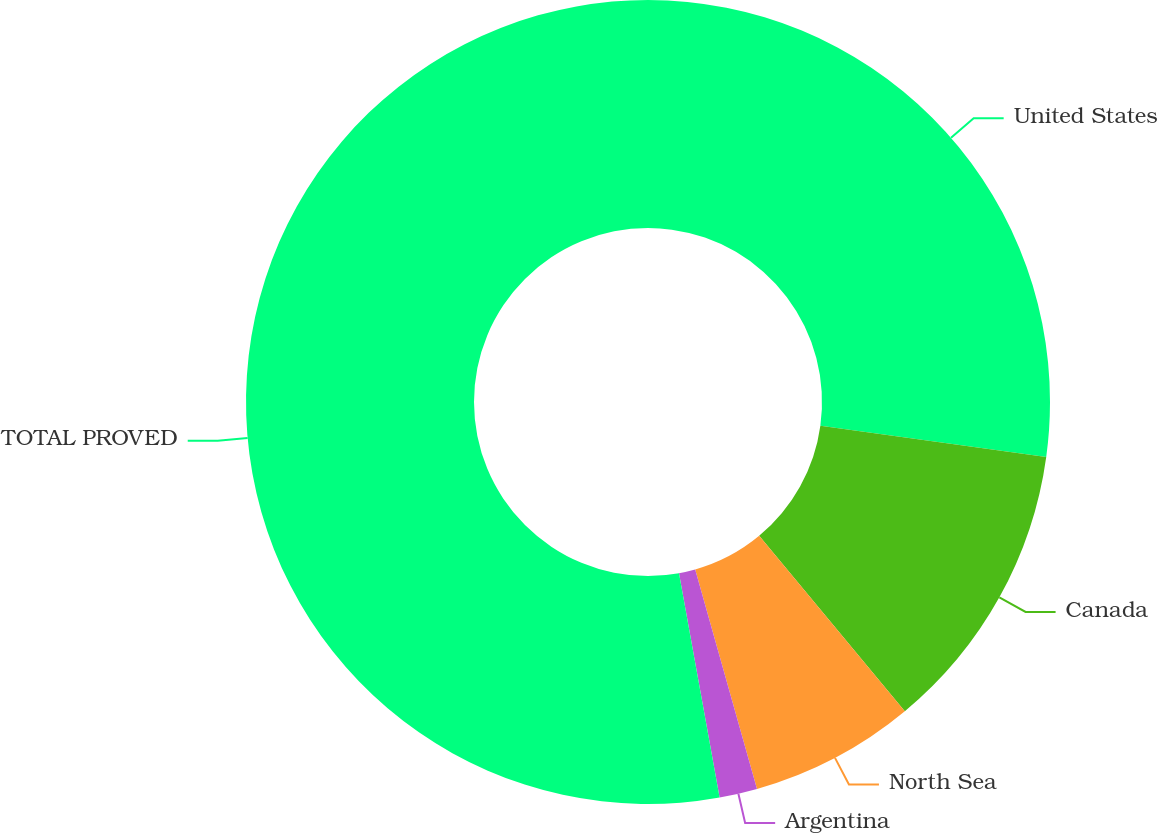Convert chart. <chart><loc_0><loc_0><loc_500><loc_500><pie_chart><fcel>United States<fcel>Canada<fcel>North Sea<fcel>Argentina<fcel>TOTAL PROVED<nl><fcel>27.18%<fcel>11.79%<fcel>6.66%<fcel>1.52%<fcel>52.85%<nl></chart> 